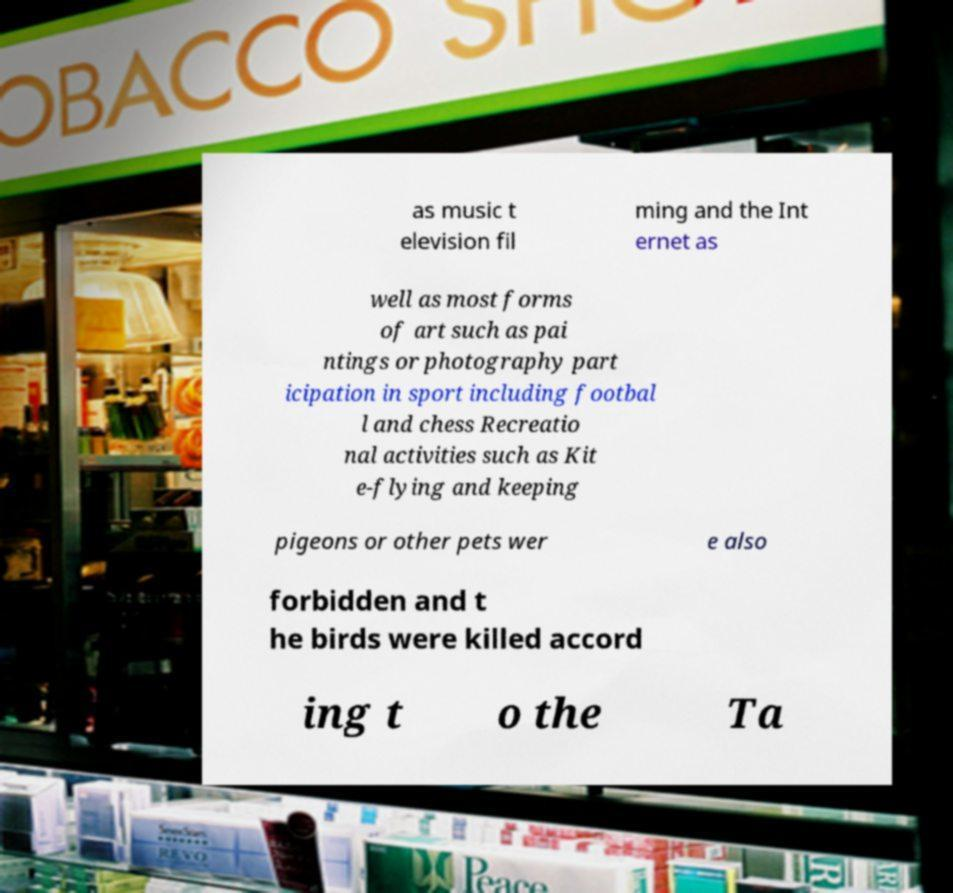What messages or text are displayed in this image? I need them in a readable, typed format. as music t elevision fil ming and the Int ernet as well as most forms of art such as pai ntings or photography part icipation in sport including footbal l and chess Recreatio nal activities such as Kit e-flying and keeping pigeons or other pets wer e also forbidden and t he birds were killed accord ing t o the Ta 